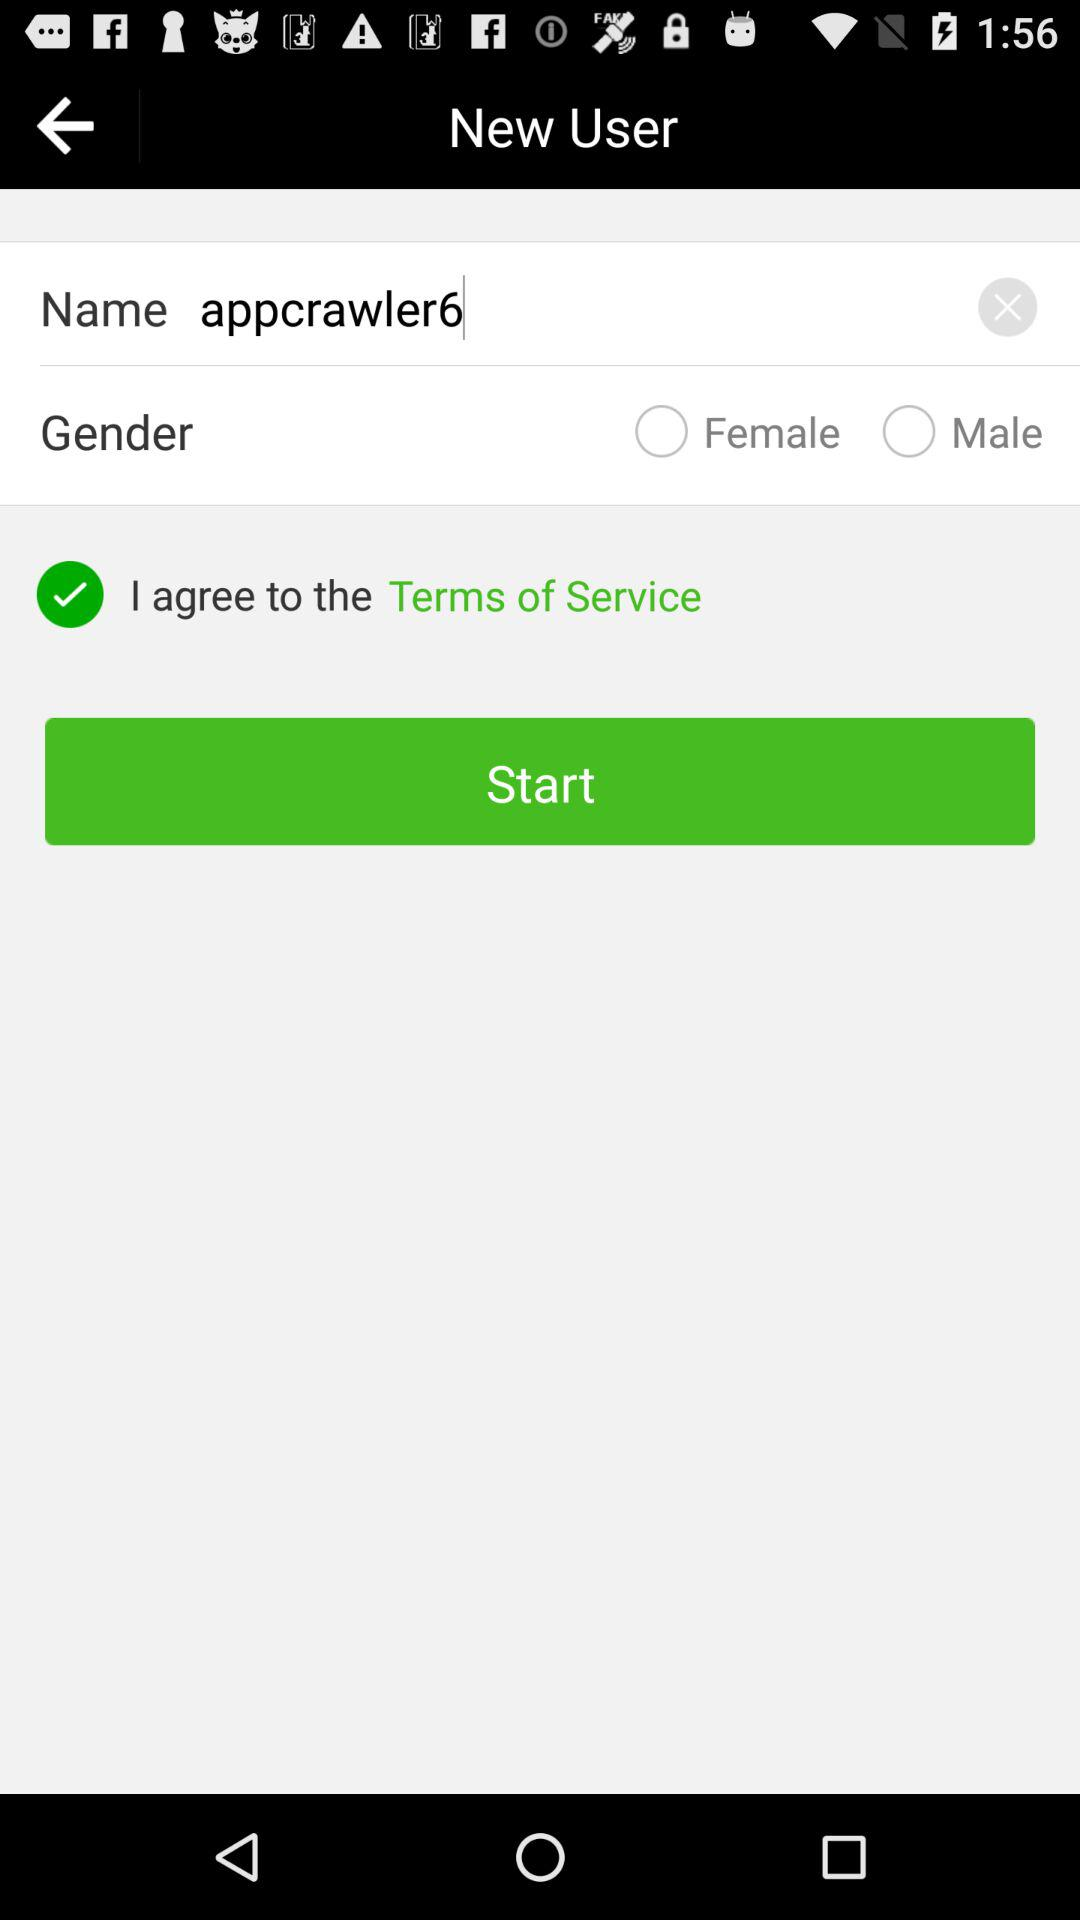What is the name? The name is "appcrawler6". 